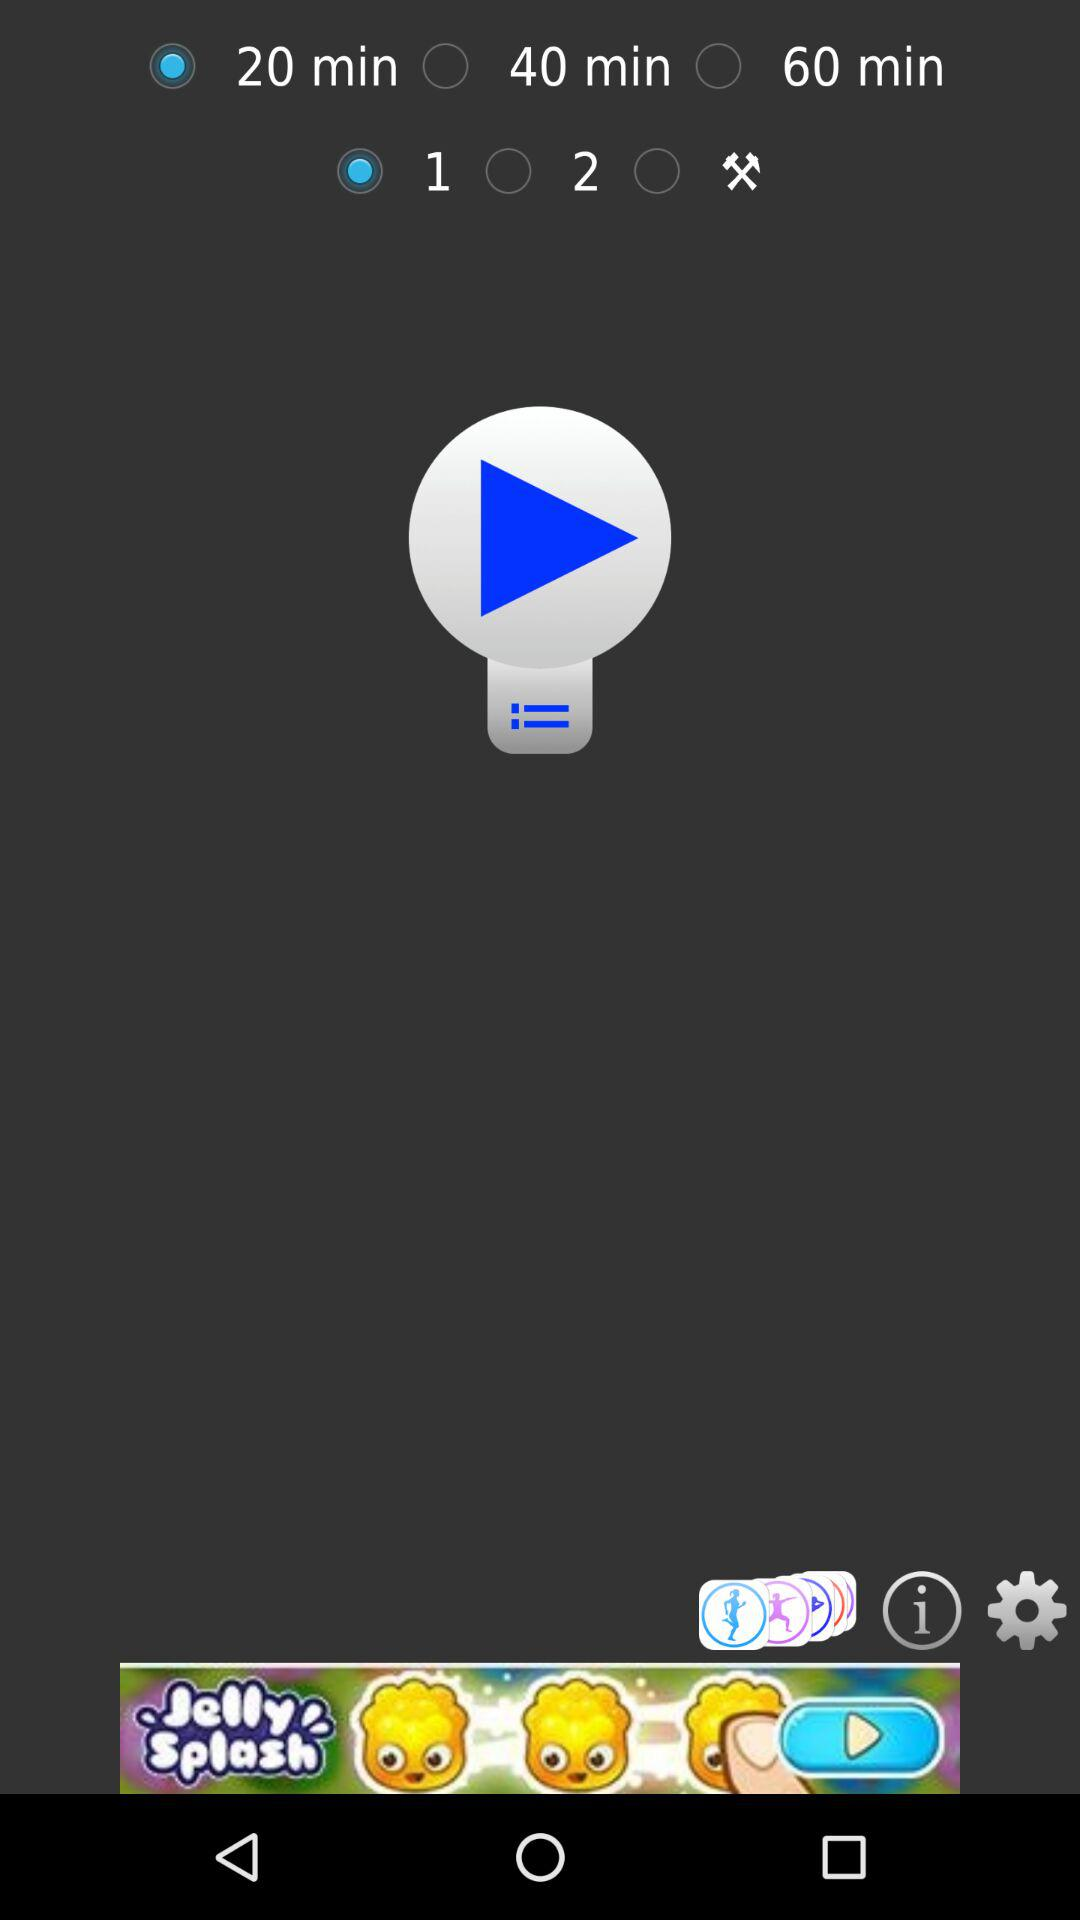What is the selected time duration? The selected time duration is 20 minutes. 